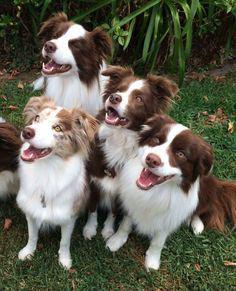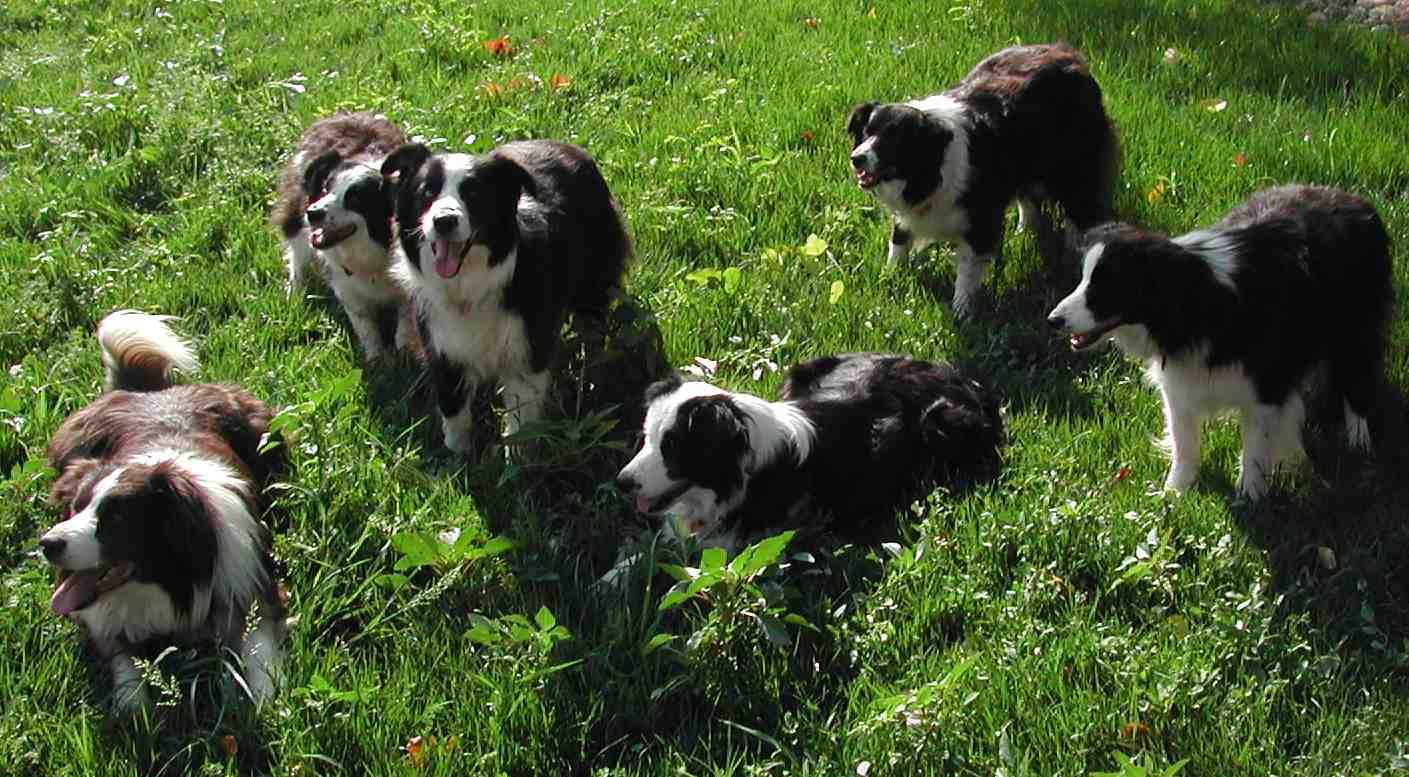The first image is the image on the left, the second image is the image on the right. Analyze the images presented: Is the assertion "There is a brown hound dog in the image on the left." valid? Answer yes or no. No. 